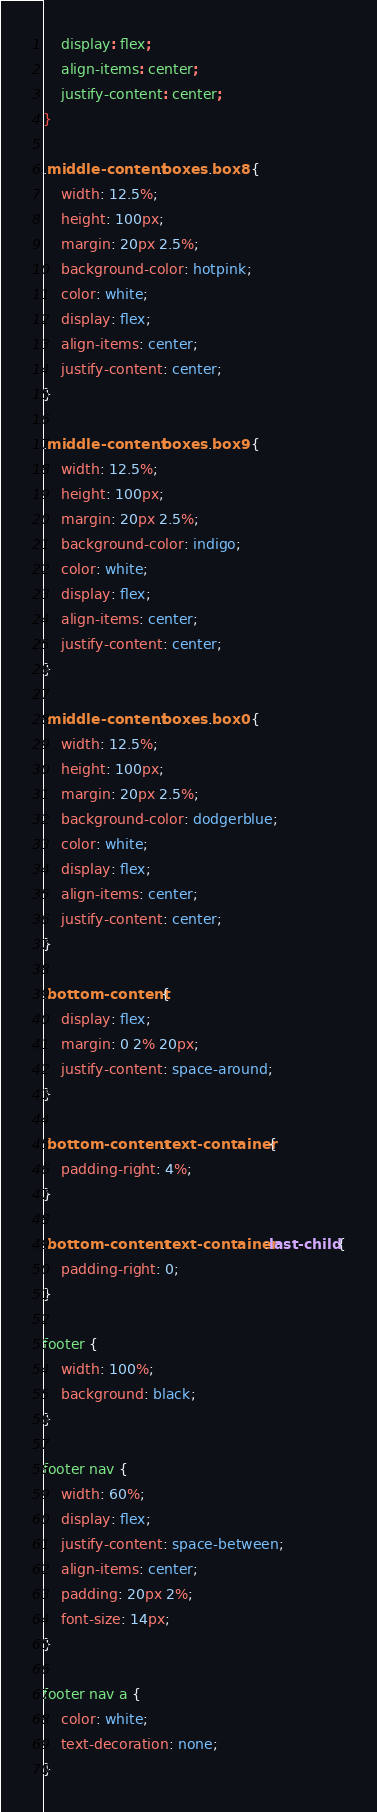<code> <loc_0><loc_0><loc_500><loc_500><_CSS_>    display: flex;
    align-items: center;
    justify-content: center;
}

.middle-content .boxes .box8 {
    width: 12.5%;
    height: 100px;
    margin: 20px 2.5%;
    background-color: hotpink;
    color: white;
    display: flex;
    align-items: center;
    justify-content: center;
}

.middle-content .boxes .box9 {
    width: 12.5%;
    height: 100px;
    margin: 20px 2.5%;
    background-color: indigo;
    color: white;
    display: flex;
    align-items: center;
    justify-content: center;
}

.middle-content .boxes .box0 {
    width: 12.5%;
    height: 100px;
    margin: 20px 2.5%;
    background-color: dodgerblue;
    color: white;
    display: flex;
    align-items: center;
    justify-content: center;
}

.bottom-content {
    display: flex;
    margin: 0 2% 20px;
    justify-content: space-around;
}

.bottom-content .text-container {
    padding-right: 4%;
}

.bottom-content .text-container:last-child {
    padding-right: 0;
}

footer {
    width: 100%;
    background: black;
}

footer nav {
    width: 60%;
    display: flex;
    justify-content: space-between;
    align-items: center;
    padding: 20px 2%;
    font-size: 14px;
}

footer nav a {
    color: white;
    text-decoration: none;
}</code> 